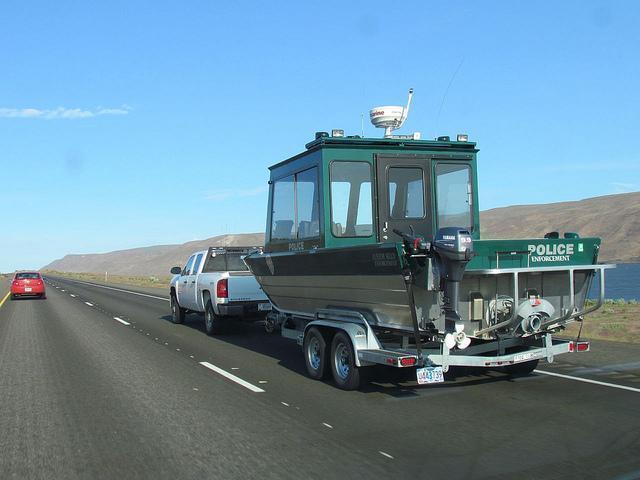How many trucks are visible?
Give a very brief answer. 2. 